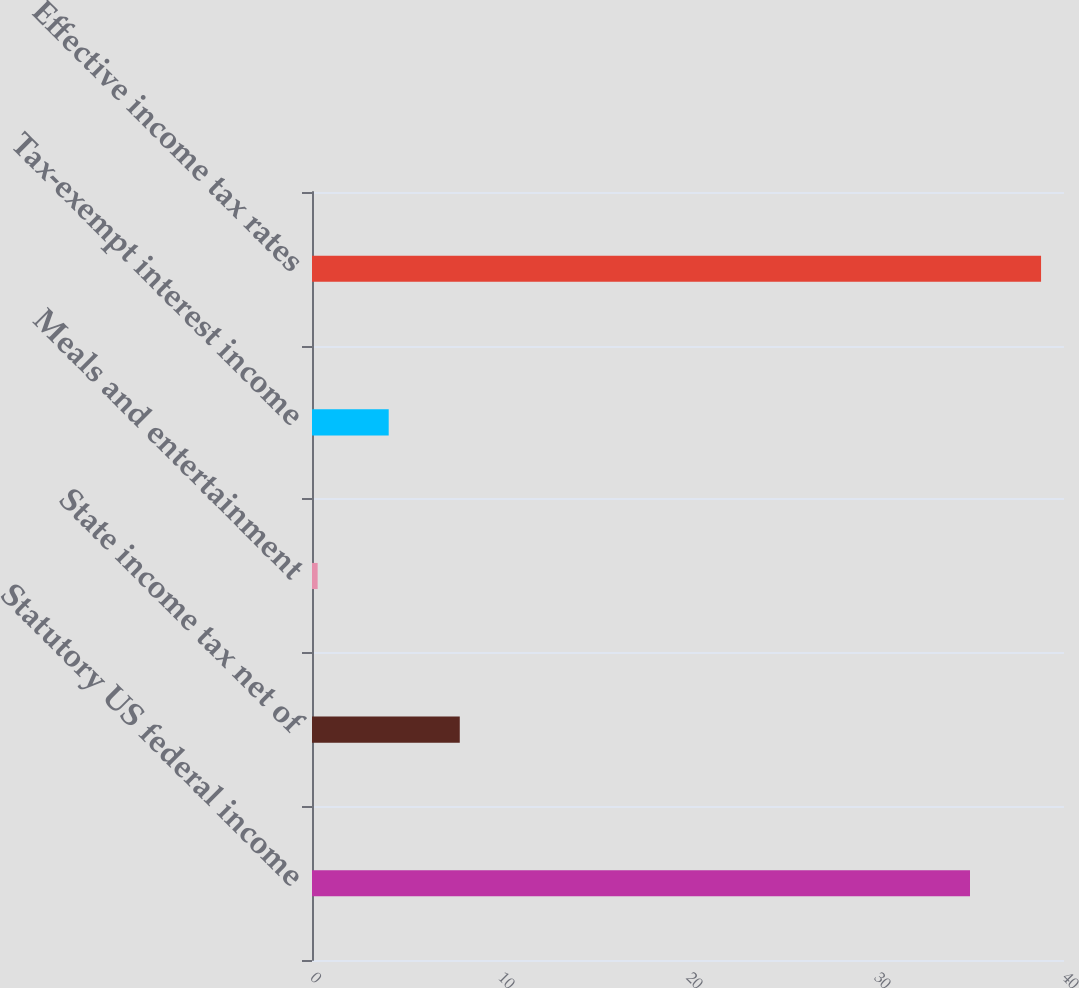Convert chart to OTSL. <chart><loc_0><loc_0><loc_500><loc_500><bar_chart><fcel>Statutory US federal income<fcel>State income tax net of<fcel>Meals and entertainment<fcel>Tax-exempt interest income<fcel>Effective income tax rates<nl><fcel>35<fcel>7.86<fcel>0.3<fcel>4.08<fcel>38.78<nl></chart> 